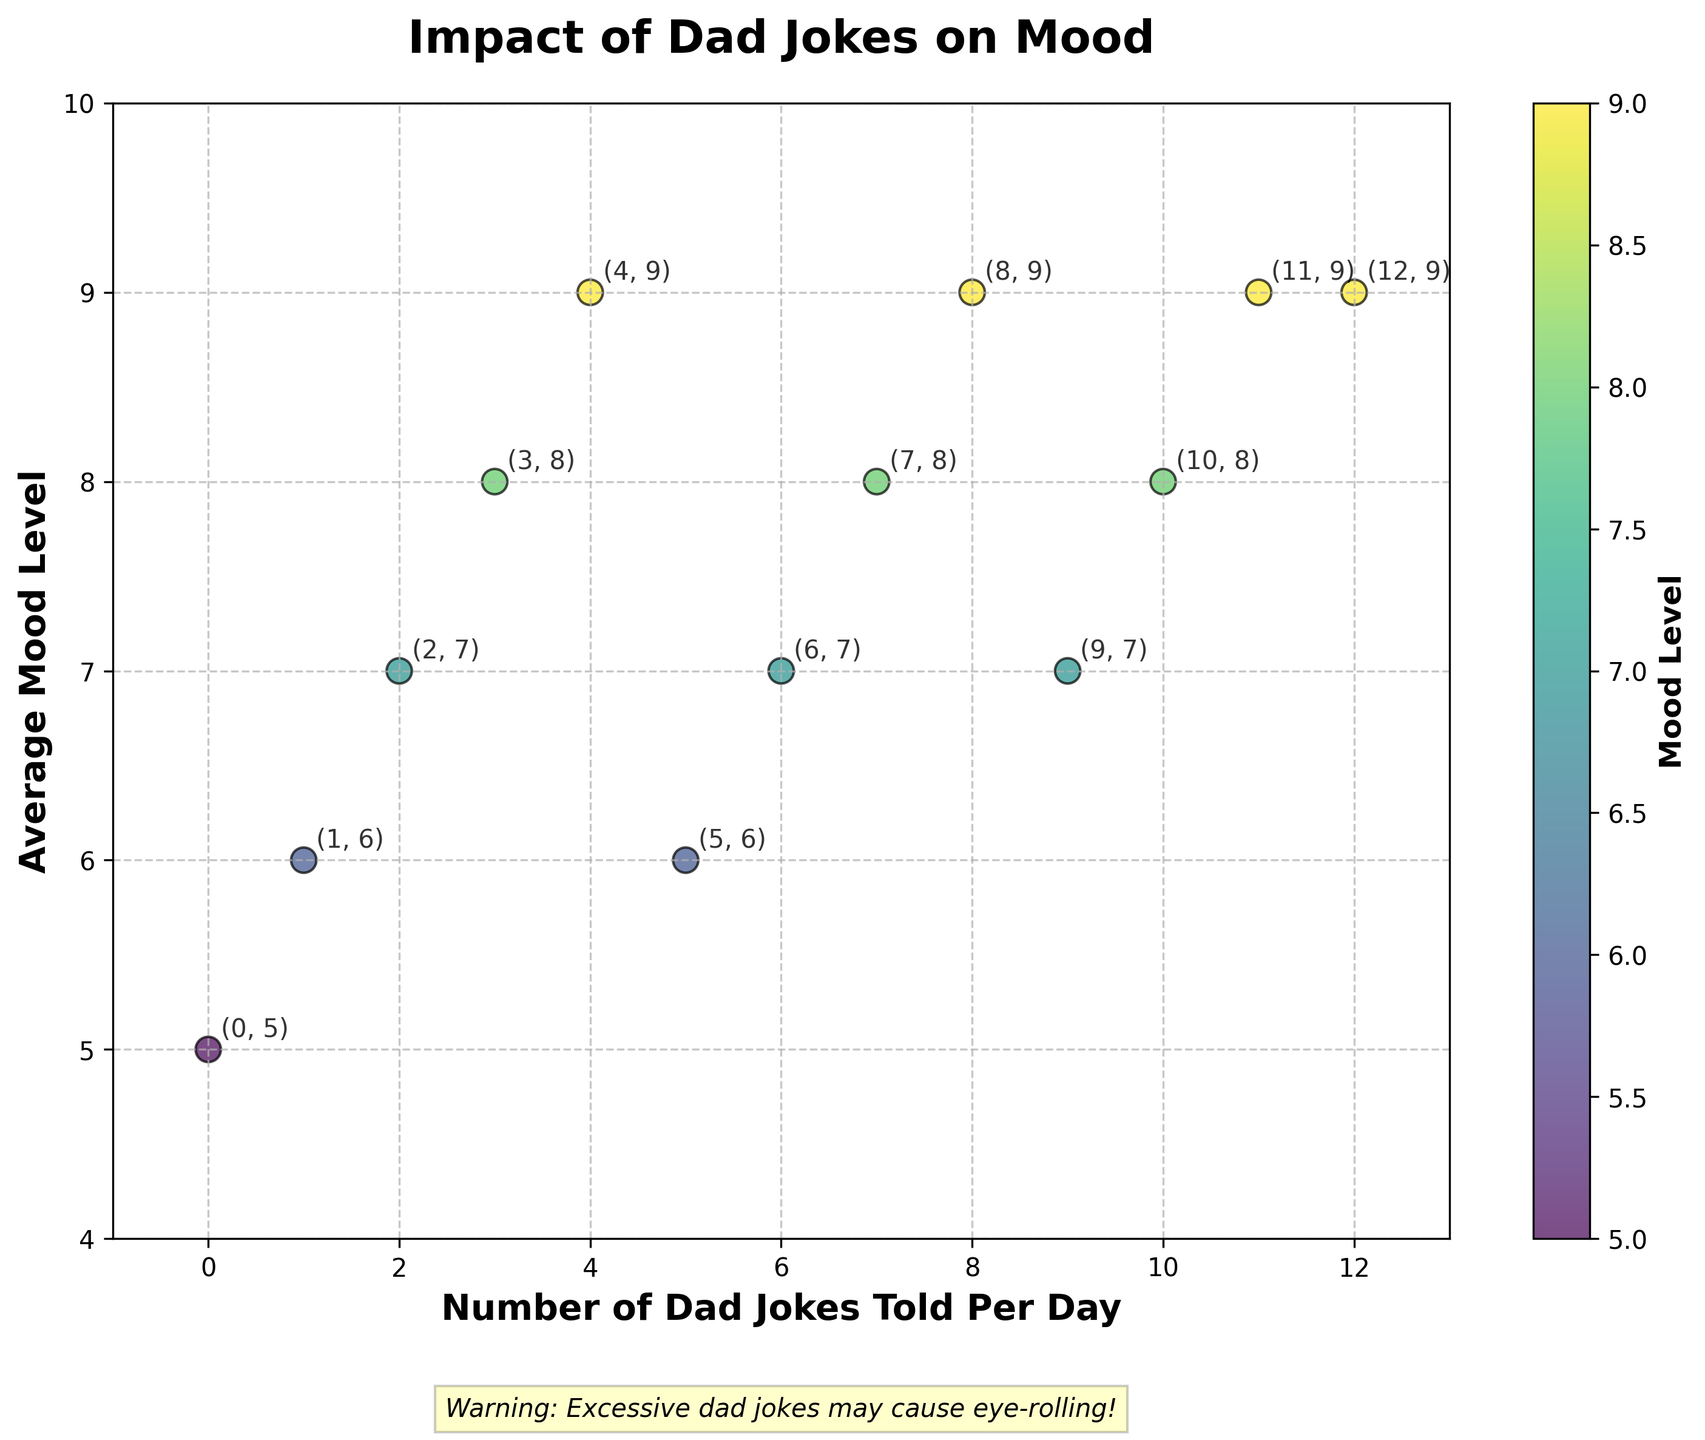How many data points are plotted on the scatter plot? There are 13 different pairs of (DadJokesPerDay, AverageMoodLevel) provided in the data. Each pair represents a data point plotted on the scatter plot.
Answer: 13 What are the labels of the X and Y axes? The X-axis is labelled "Number of Dad Jokes Told Per Day" and the Y-axis is labelled "Average Mood Level".
Answer: Number of Dad Jokes Told Per Day, Average Mood Level What is the title of the scatter plot? The title of the scatter plot is "Impact of Dad Jokes on Mood".
Answer: Impact of Dad Jokes on Mood What is the average mood level when 5 dad jokes are told per day? Looking at the data point (5, 6), the average mood level when 5 dad jokes are told per day is 6.
Answer: 6 Is there any text annotation outside the main plot area? If yes, what does it say? Yes, there is a text annotation below the main plot area that says "Warning: Excessive dad jokes may cause eye-rolling!"
Answer: Warning: Excessive dad jokes may cause eye-rolling! What average mood level appears frequently among the data points when the number of dad jokes increases from 8 to 12 per day? As we examine the data points for DadJokesPerDay values from 8 to 12, we see that the average mood levels are 9, 7, 8, 9, and 9. The value 9 appears most frequently in this range.
Answer: 9 What is the range of the mood levels shown in the scatter plot? By examining the Y-axis limits, which range from 4 to 10, and the data points which show the mood levels, the range of the mood levels is from 5 to 9.
Answer: 5 to 9 What kind of color gradient is used for the data points in the scatter plot? The data points in the scatter plot use a color gradient that goes from lighter to darker shades, which is typical of a colormap like 'viridis'.
Answer: viridis How does the average mood level change as the number of dad jokes increases from 0 to 4 per day? Observing the data points from (0, 5) to (4, 9), the average mood level increases roughly in a linear fashion from 5 to 9 as the number of dad jokes increases from 0 to 4 per day.
Answer: Increases linearly Which data point has the highest average mood level and what is that mood level? The data points (4, 9), (8, 9), (11, 9), and (12, 9) have the highest average mood level, which is 9.
Answer: (4, 9), (8, 9), (11, 9), (12, 9) 